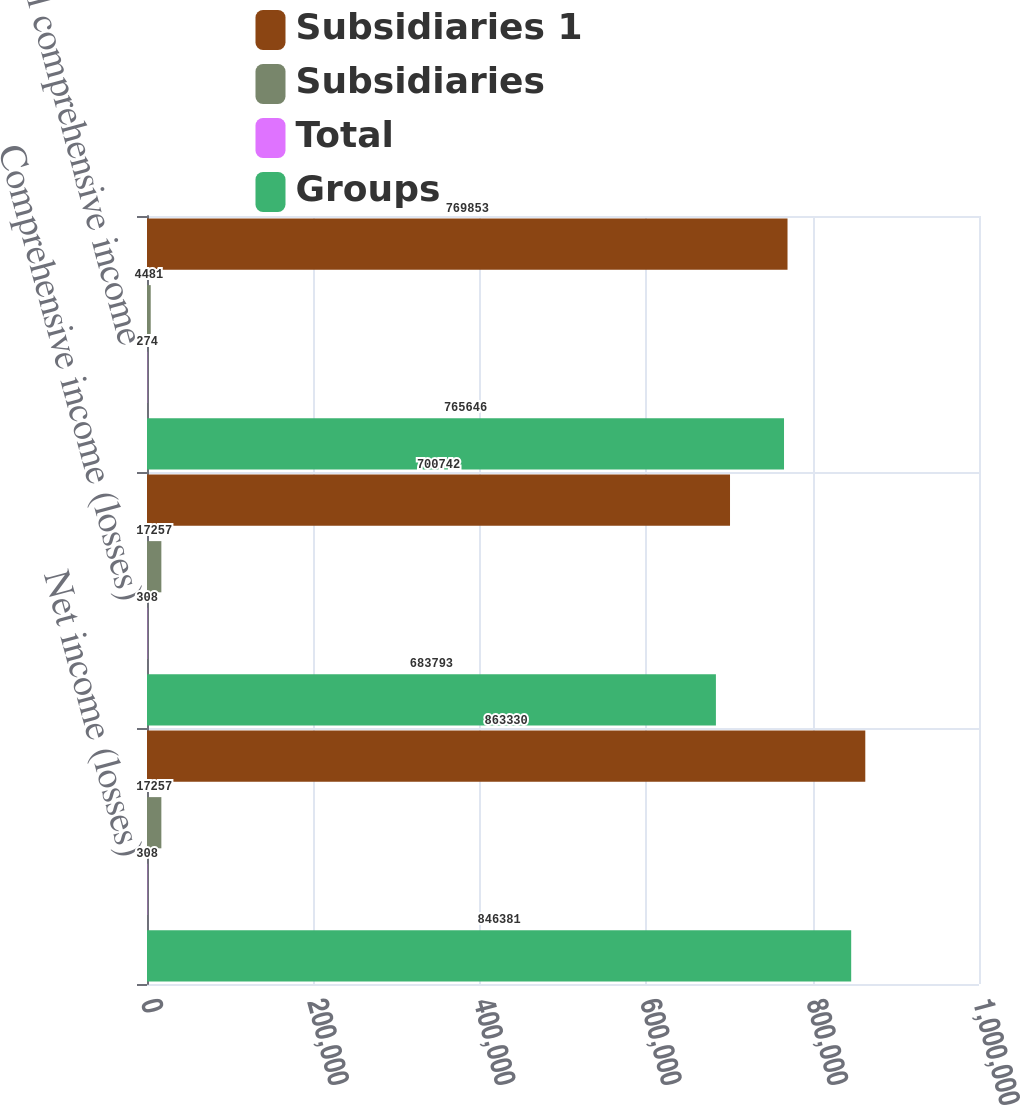Convert chart to OTSL. <chart><loc_0><loc_0><loc_500><loc_500><stacked_bar_chart><ecel><fcel>Net income (losses)<fcel>Comprehensive income (losses)<fcel>Total comprehensive income<nl><fcel>Subsidiaries 1<fcel>863330<fcel>700742<fcel>769853<nl><fcel>Subsidiaries<fcel>17257<fcel>17257<fcel>4481<nl><fcel>Total<fcel>308<fcel>308<fcel>274<nl><fcel>Groups<fcel>846381<fcel>683793<fcel>765646<nl></chart> 